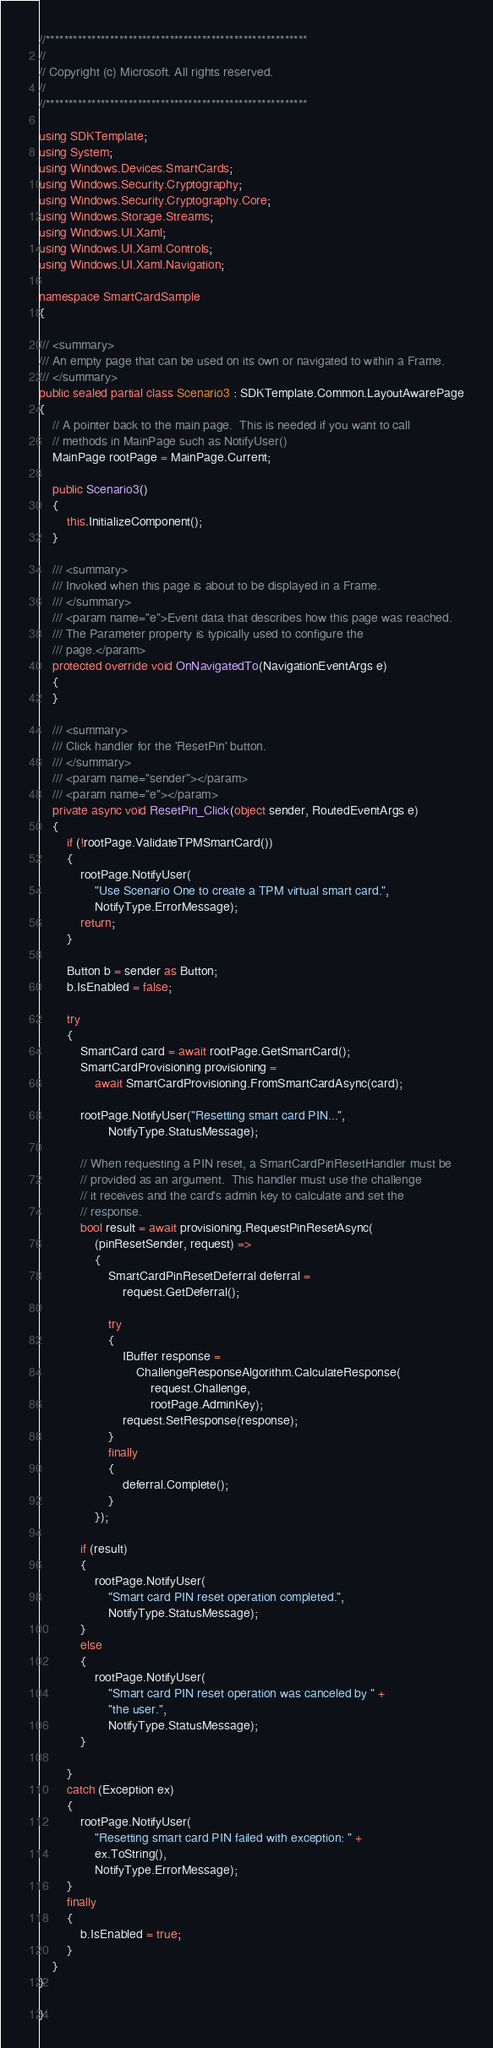Convert code to text. <code><loc_0><loc_0><loc_500><loc_500><_C#_>//*********************************************************
//
// Copyright (c) Microsoft. All rights reserved.
//
//*********************************************************

using SDKTemplate;
using System;
using Windows.Devices.SmartCards;
using Windows.Security.Cryptography;
using Windows.Security.Cryptography.Core;
using Windows.Storage.Streams;
using Windows.UI.Xaml;
using Windows.UI.Xaml.Controls;
using Windows.UI.Xaml.Navigation;

namespace SmartCardSample
{

/// <summary>
/// An empty page that can be used on its own or navigated to within a Frame.
/// </summary>
public sealed partial class Scenario3 : SDKTemplate.Common.LayoutAwarePage
{
    // A pointer back to the main page.  This is needed if you want to call
    // methods in MainPage such as NotifyUser()
    MainPage rootPage = MainPage.Current;

    public Scenario3()
    {
        this.InitializeComponent();
    }

    /// <summary>
    /// Invoked when this page is about to be displayed in a Frame.
    /// </summary>
    /// <param name="e">Event data that describes how this page was reached.
    /// The Parameter property is typically used to configure the
    /// page.</param>
    protected override void OnNavigatedTo(NavigationEventArgs e)
    {
    }

    /// <summary>
    /// Click handler for the 'ResetPin' button. 
    /// </summary>
    /// <param name="sender"></param>
    /// <param name="e"></param>
    private async void ResetPin_Click(object sender, RoutedEventArgs e)
    {
        if (!rootPage.ValidateTPMSmartCard())
        {
            rootPage.NotifyUser(
                "Use Scenario One to create a TPM virtual smart card.",
                NotifyType.ErrorMessage);
            return;
        }

        Button b = sender as Button;
        b.IsEnabled = false;
        
        try
        {
            SmartCard card = await rootPage.GetSmartCard();
            SmartCardProvisioning provisioning =
                await SmartCardProvisioning.FromSmartCardAsync(card);

            rootPage.NotifyUser("Resetting smart card PIN...",
                    NotifyType.StatusMessage);

            // When requesting a PIN reset, a SmartCardPinResetHandler must be
            // provided as an argument.  This handler must use the challenge
            // it receives and the card's admin key to calculate and set the
            // response.
            bool result = await provisioning.RequestPinResetAsync(
                (pinResetSender, request) =>
                {
                    SmartCardPinResetDeferral deferral =
                        request.GetDeferral();

                    try
                    {
                        IBuffer response =
                            ChallengeResponseAlgorithm.CalculateResponse(
                                request.Challenge,
                                rootPage.AdminKey);
                        request.SetResponse(response);
                    }
                    finally
                    {
                        deferral.Complete();
                    }
                });

            if (result)
            {
                rootPage.NotifyUser(
                    "Smart card PIN reset operation completed.",
                    NotifyType.StatusMessage);
            }
            else
            {
                rootPage.NotifyUser(
                    "Smart card PIN reset operation was canceled by " +
                    "the user.",
                    NotifyType.StatusMessage);
            }
            
        }
        catch (Exception ex)
        {
            rootPage.NotifyUser(
                "Resetting smart card PIN failed with exception: " +
                ex.ToString(),
                NotifyType.ErrorMessage);
        }
        finally
        {
            b.IsEnabled = true;
        }
    }
}

}
</code> 